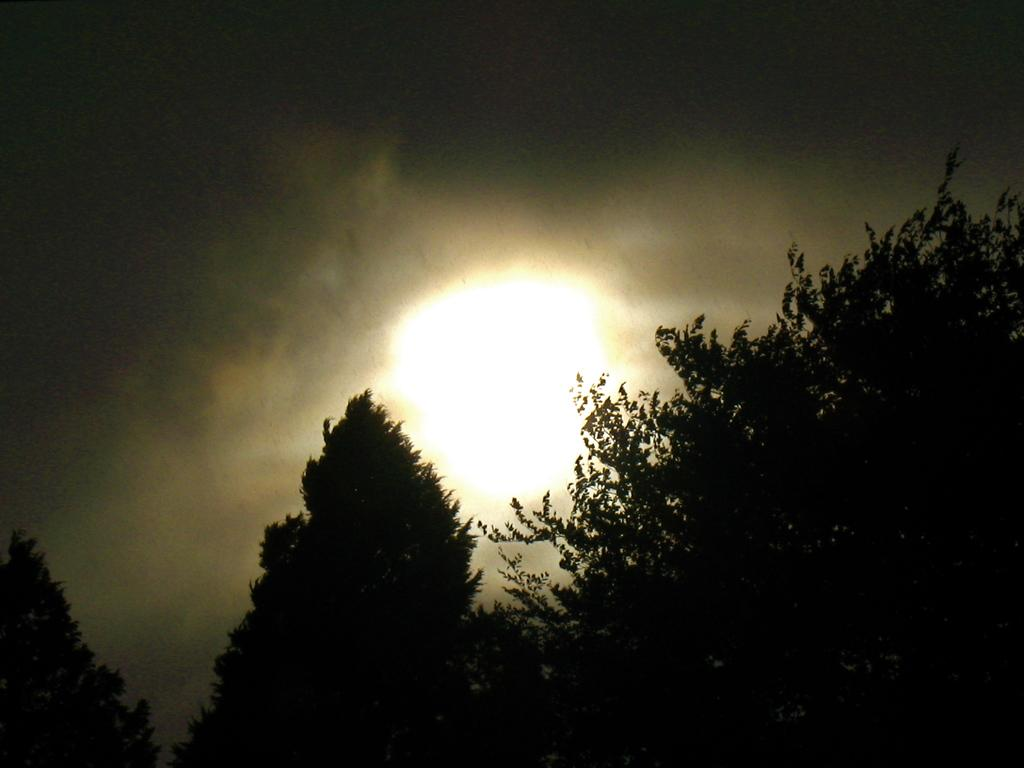What type of vegetation can be seen in the image? There are trees present in the image. What celestial body is visible in the sky? The sun is visible in the sky. What else can be seen in the sky besides the sun? Clouds are present in the sky. What is the limit of the competition between the trees in the image? There is no competition between the trees in the image, and therefore no limit can be determined. 